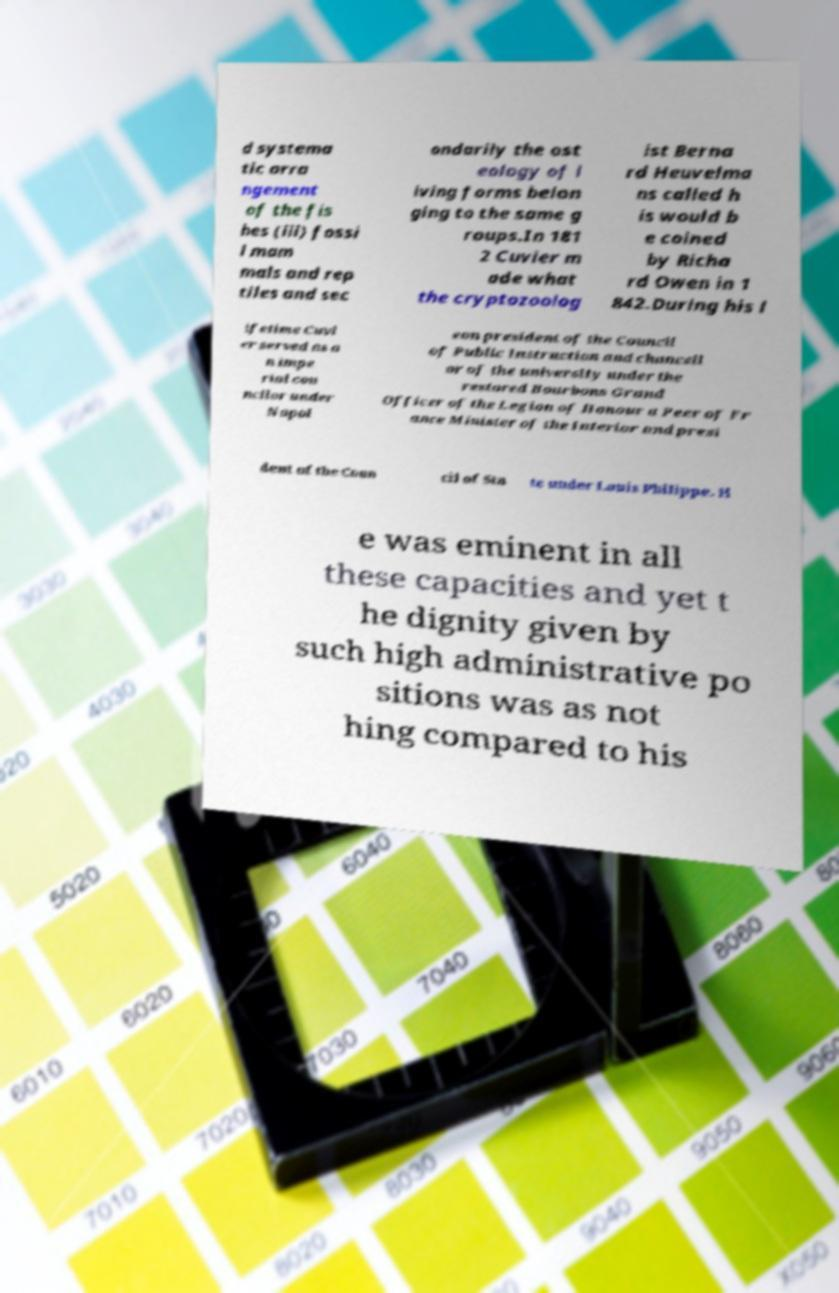Can you accurately transcribe the text from the provided image for me? d systema tic arra ngement of the fis hes (iii) fossi l mam mals and rep tiles and sec ondarily the ost eology of l iving forms belon ging to the same g roups.In 181 2 Cuvier m ade what the cryptozoolog ist Berna rd Heuvelma ns called h is would b e coined by Richa rd Owen in 1 842.During his l ifetime Cuvi er served as a n impe rial cou ncilor under Napol eon president of the Council of Public Instruction and chancell or of the university under the restored Bourbons Grand Officer of the Legion of Honour a Peer of Fr ance Minister of the Interior and presi dent of the Coun cil of Sta te under Louis Philippe. H e was eminent in all these capacities and yet t he dignity given by such high administrative po sitions was as not hing compared to his 